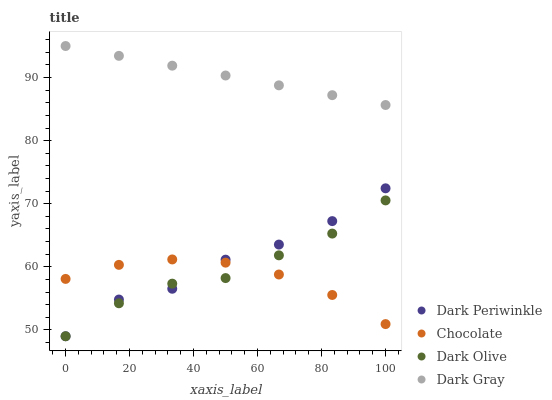Does Chocolate have the minimum area under the curve?
Answer yes or no. Yes. Does Dark Gray have the maximum area under the curve?
Answer yes or no. Yes. Does Dark Olive have the minimum area under the curve?
Answer yes or no. No. Does Dark Olive have the maximum area under the curve?
Answer yes or no. No. Is Dark Gray the smoothest?
Answer yes or no. Yes. Is Dark Periwinkle the roughest?
Answer yes or no. Yes. Is Dark Olive the smoothest?
Answer yes or no. No. Is Dark Olive the roughest?
Answer yes or no. No. Does Dark Olive have the lowest value?
Answer yes or no. Yes. Does Chocolate have the lowest value?
Answer yes or no. No. Does Dark Gray have the highest value?
Answer yes or no. Yes. Does Dark Olive have the highest value?
Answer yes or no. No. Is Dark Periwinkle less than Dark Gray?
Answer yes or no. Yes. Is Dark Gray greater than Dark Periwinkle?
Answer yes or no. Yes. Does Dark Olive intersect Dark Periwinkle?
Answer yes or no. Yes. Is Dark Olive less than Dark Periwinkle?
Answer yes or no. No. Is Dark Olive greater than Dark Periwinkle?
Answer yes or no. No. Does Dark Periwinkle intersect Dark Gray?
Answer yes or no. No. 